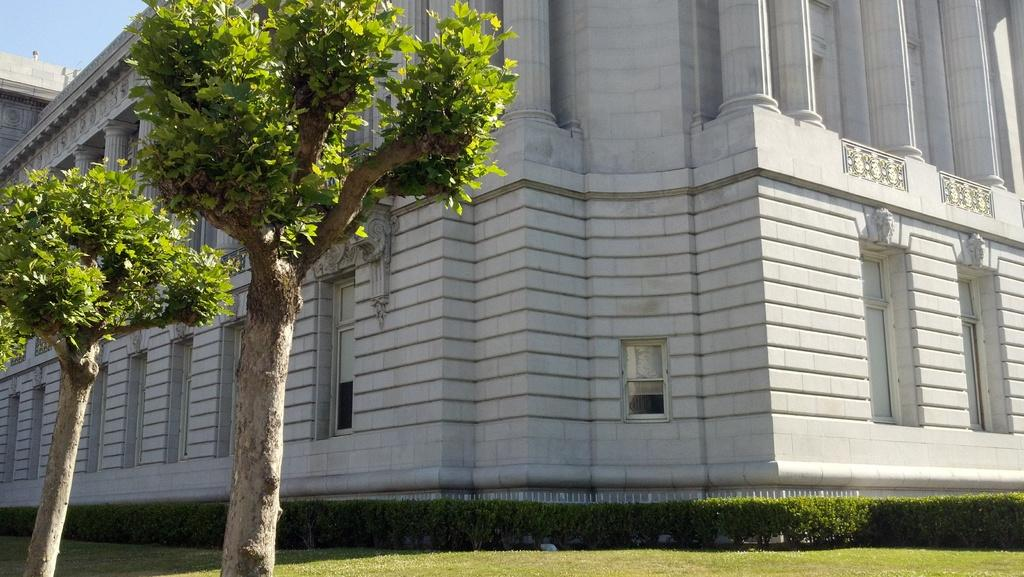How many trees are on the grassland in the image? There are two trees on the grassland in the image. What else can be found on the grassland besides trees? There are plants on the grassland. What structure is visible behind the trees? There is a building behind the trees. What part of the sky is visible in the image? The sky is visible in the top left corner of the image. Can you tell me how many times the brain is mentioned in the image? There is no mention of a brain in the image, as it focuses on trees, plants, a building, and the sky. 